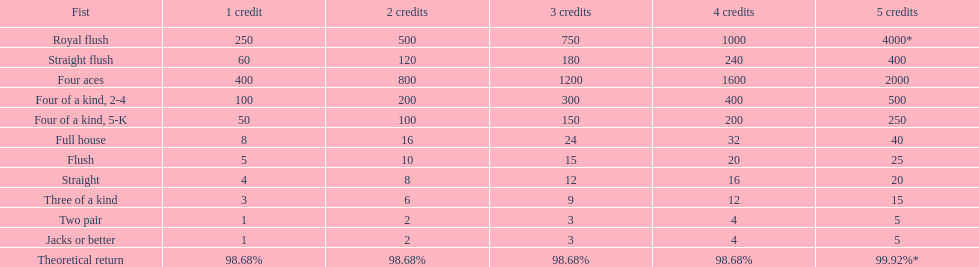For a one credit stake on a royal flush, what is the number of credits earned? 250. 